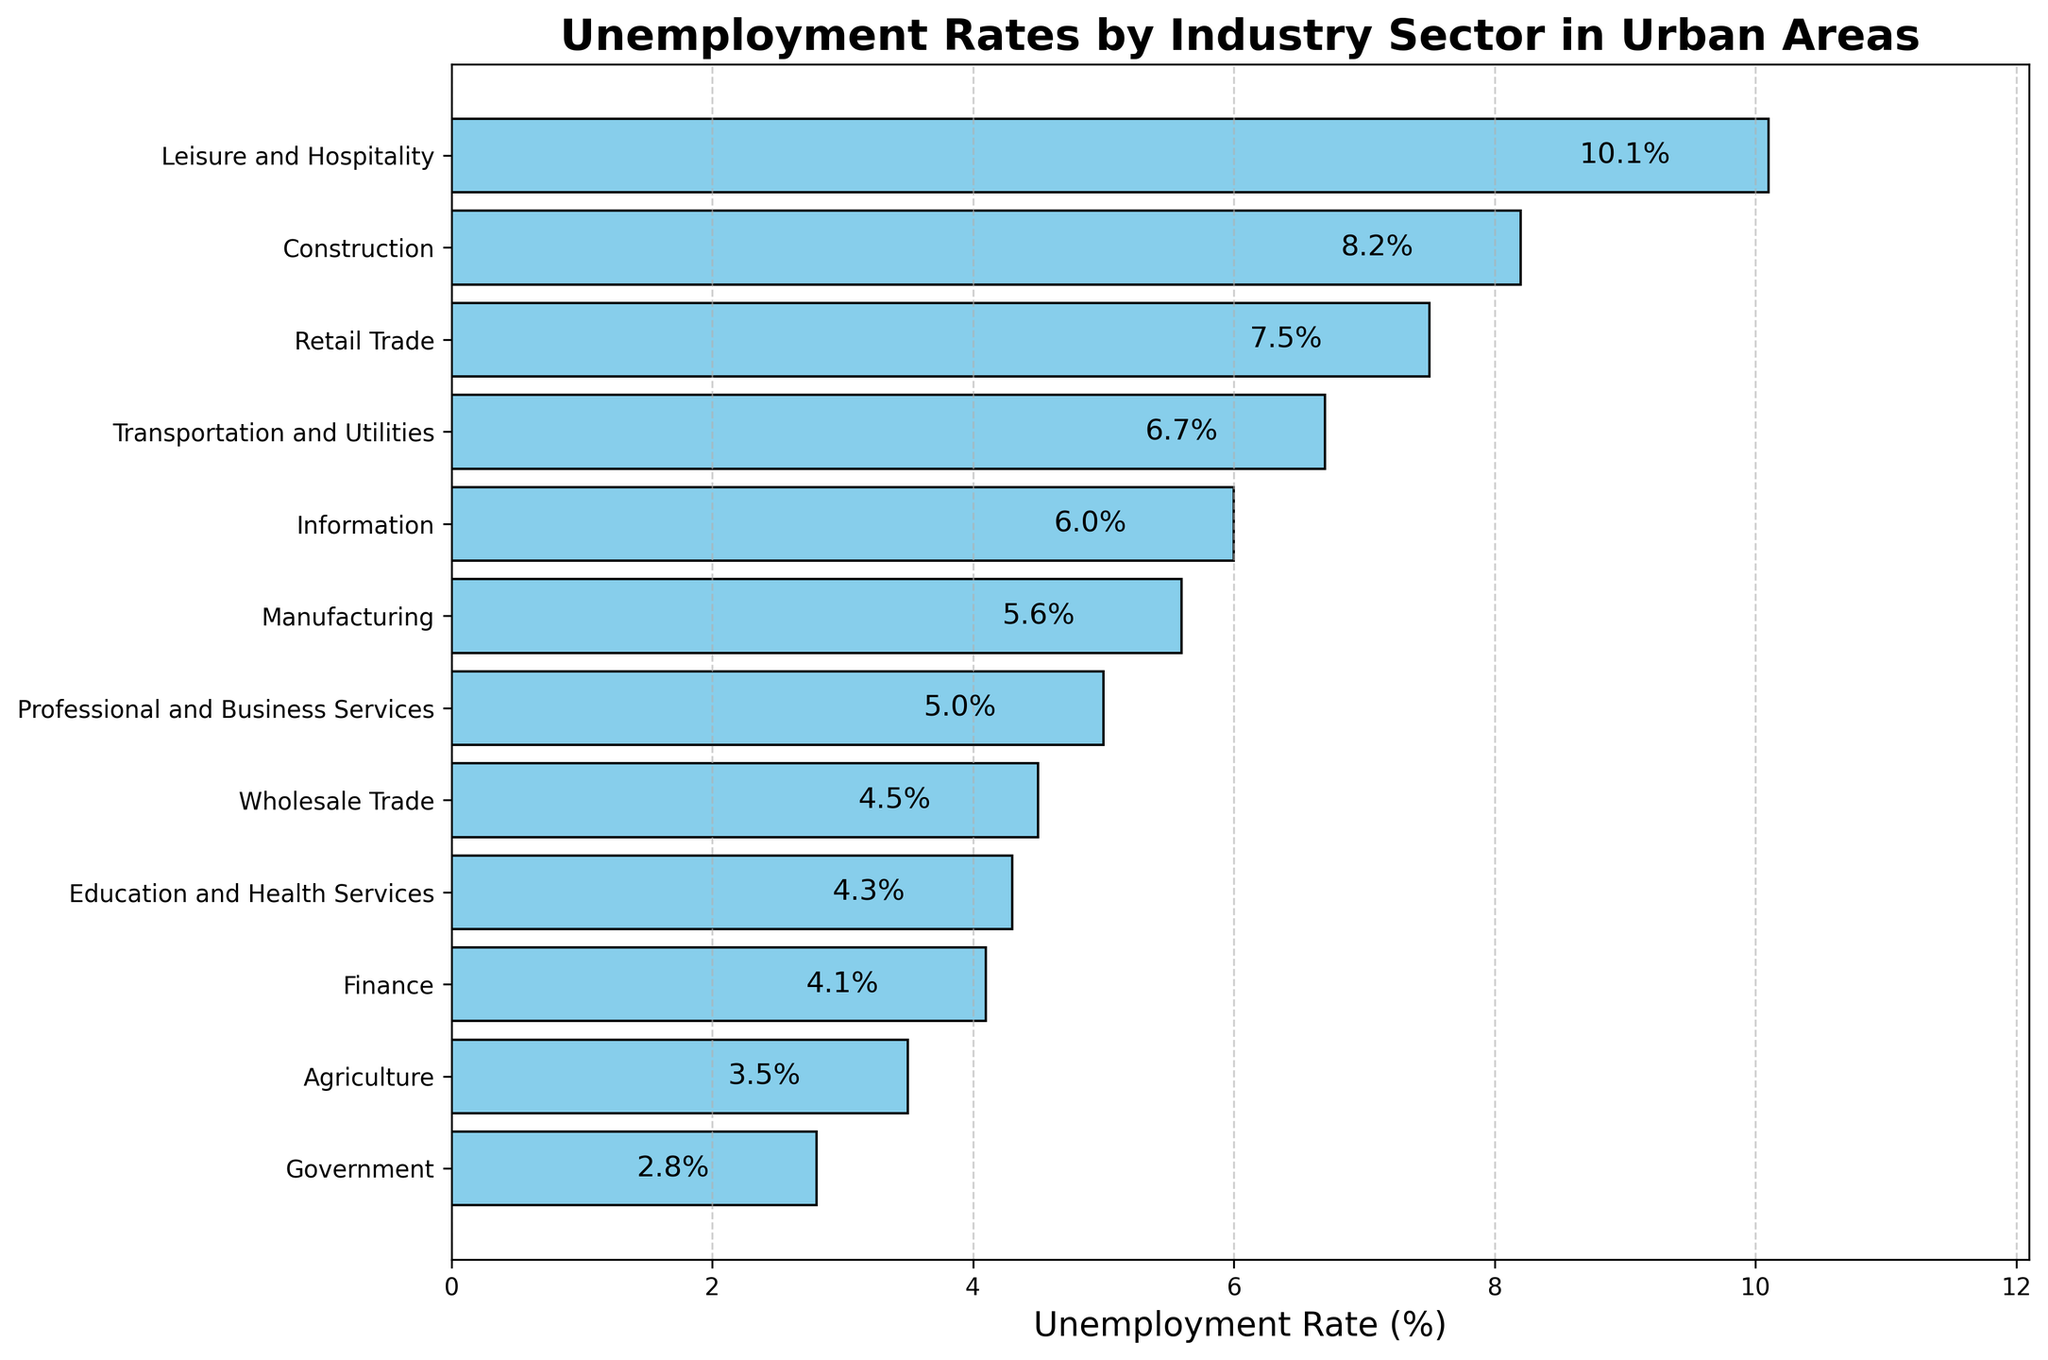What is the industry sector with the highest unemployment rate? The plot's bars show unemployment rates for each sector. The bar with the highest length represents Leisure and Hospitality with a rate of 10.1%.
Answer: Leisure and Hospitality What is the difference in the unemployment rate between the Government and Construction sectors? The Government sector has an unemployment rate of 2.8%, while Construction has 8.2%. The difference between them is 8.2% - 2.8% = 5.4%.
Answer: 5.4% Which sectors have an unemployment rate lower than 5%? From the plot, we can see the sectors with unemployment rates lower than 5%: Agriculture, Government, Finance, and Education and Health Services.
Answer: Agriculture, Government, Finance, Education and Health Services How many sectors have an unemployment rate higher than 6%? By visually inspecting the bars, we can see the sectors with rates higher than 6%: Construction, Leisure and Hospitality, Retail Trade, Transportation and Utilities, and Information. There are 5 such sectors.
Answer: 5 What is the average unemployment rate of the Retail Trade, Finance, and Information sectors? The unemployment rates for Retail Trade, Finance, and Information are 7.5%, 4.1%, and 6.0%, respectively. Their average is (7.5 + 4.1 + 6.0) / 3 = 5.87%.
Answer: 5.87% Which sector has the smallest unemployment rate? The bar with the shortest length represents the Government sector with a rate of 2.8%.
Answer: Government What is the median unemployment rate among all sectors? To find the median, arrange the rates in order and find the middle value. Ordered rates: [2.8, 3.5, 4.1, 4.3, 4.5, 5.0, 5.6, 6.0, 6.7, 7.5, 8.2, 10.1]. The middle values are 5.0 and 5.6, and their average is (5.0 + 5.6) / 2 = 5.3%.
Answer: 5.3% Which sector has a visually distinctively higher unemployment rate compared to others? Visually distinctive bars are typically much higher than others, and Leisure and Hospitality's bar is noticeably higher, showing a rate of 10.1%.
Answer: Leisure and Hospitality By how much does the unemployment rate in Manufacturing exceed that in Finance? Manufacturing has a rate of 5.6%, while Finance has 4.1%. The difference is 5.6% - 4.1% = 1.5%.
Answer: 1.5% What is the unemployment rate of the sector with the second-highest unemployment rate? The two tallest bars indicate the two highest rates. The highest is Leisure and Hospitality (10.1%), and the second highest is Construction at 8.2%.
Answer: 8.2% 